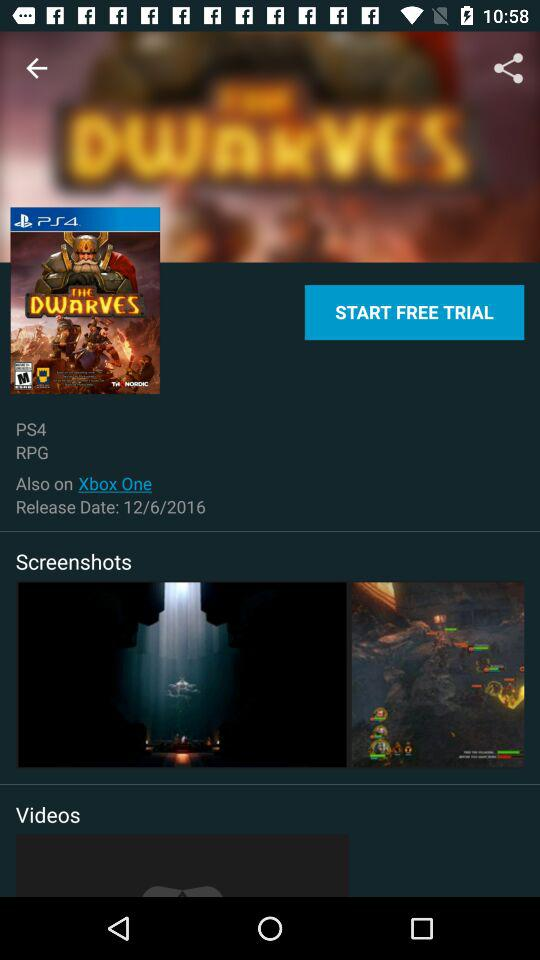What is the game name? The name of the game is "THE DWARVES". 